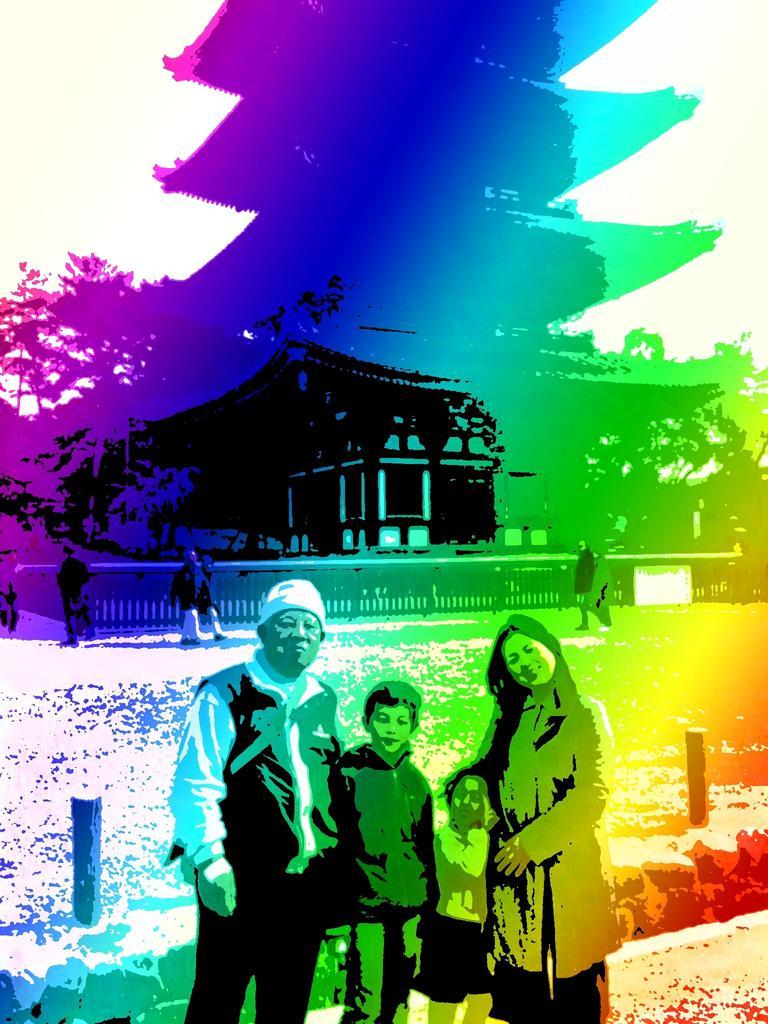Describe this image in one or two sentences. In this image I can see it is an edited image, at the bottom four persons are standing, at the back side it looks like a house. On the left side there are trees. 